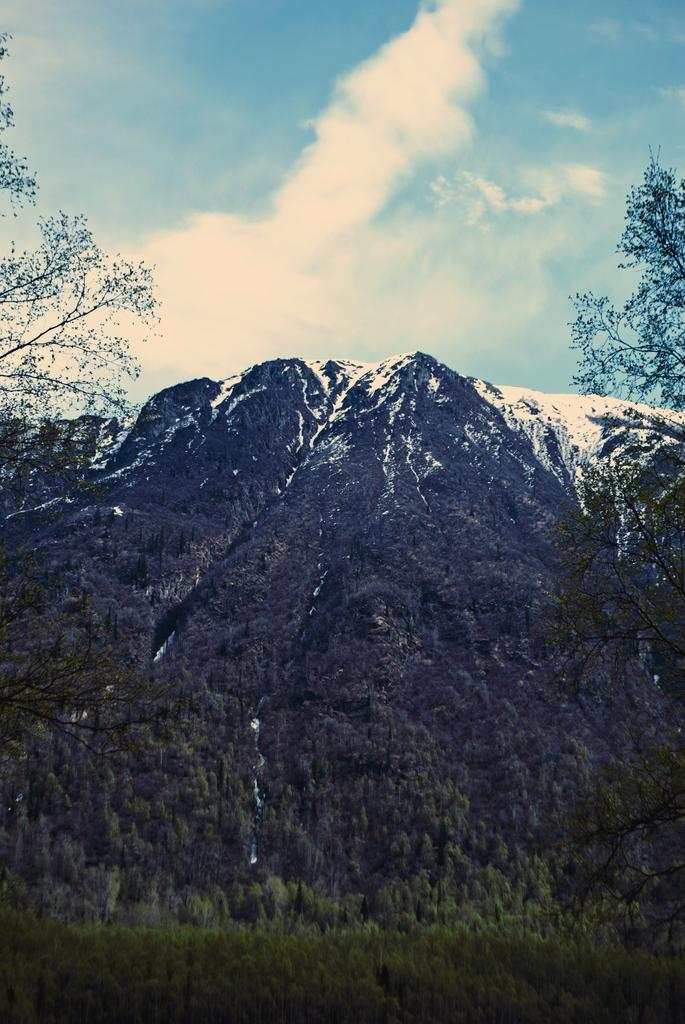What type of natural formation can be seen in the image? The image contains mountains. What is covering the mountains? The mountains are covered with plants. What is the weather like on the mountains? There is snow on the mountains, indicating cold weather. What is visible in the sky at the top of the image? Clouds are visible in the sky at the top of the image. Can you see any arches or industrial buildings in the image? No, there are no arches or industrial buildings present in the image. Who is the friend that can be seen in the image? There is no friend visible in the image; it only features mountains, plants, snow, and clouds. 